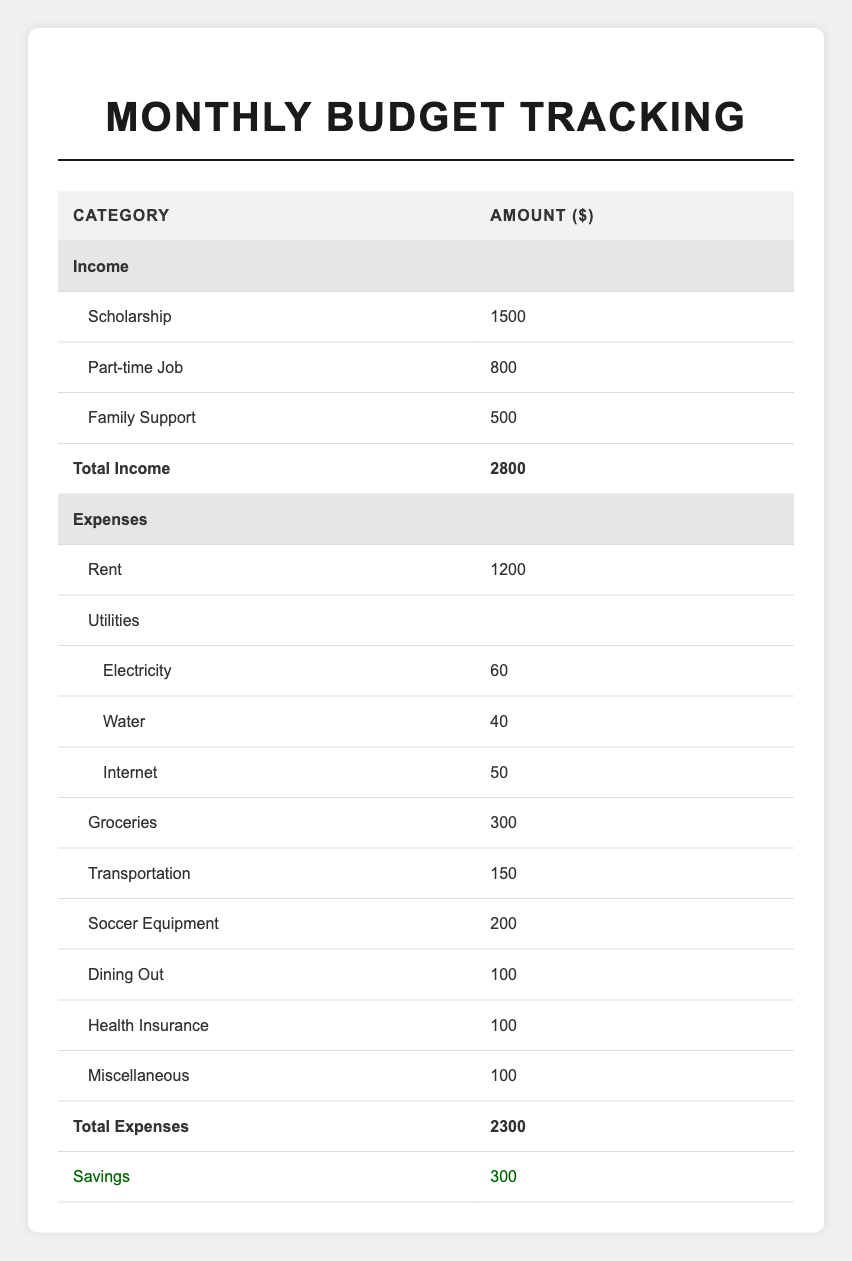What is the total income for the month? The table shows three sources of income: Scholarship (1500), Part-time Job (800), and Family Support (500). Adding these amounts together gives us 1500 + 800 + 500 = 2800.
Answer: 2800 What are the total expenses for the month? The table lists several expenses, with the total calculated as Rent (1200) + Utilities (60+40+50) + Groceries (300) + Transportation (150) + Soccer Equipment (200) + Dining Out (100) + Health Insurance (100) + Miscellaneous (100). Summing these values gives us 1200 + (60 + 40 + 50) + 300 + 150 + 200 + 100 + 100 + 100 = 2300.
Answer: 2300 What is the amount spent on utilities? The table provides the utility costs as Electricity (60), Water (40), and Internet (50). The total for utilities therefore is 60 + 40 + 50 = 150.
Answer: 150 Did the student save money this month? The table shows that the student has a savings amount of 300. Since savings are present, the answer is yes.
Answer: Yes How much more money does the student make than they spend? To determine this, we take the total income (2800) and subtract the total expenses (2300): 2800 - 2300 = 500.
Answer: 500 What percentage of their income did the student spend on rent? The rent expense is 1200 and total income is 2800. The calculation is (1200 / 2800) * 100, which equals approximately 42.86%.
Answer: 42.86% If the student wants to save an additional 200 next month, how much can they spend on expenses? The student currently saves 300. To save an additional 200, they would want to save a total of 500. To find the maximum spending limit, we subtract the desired savings from total income: 2800 - 500 = 2300. Thus, they can spend 2300 on expenses.
Answer: 2300 What categories have expenses less than 200 dollars? The table lists expenses for “Dining Out” (100), “Health Insurance” (100), and “Miscellaneous” (100) as categories with amounts below 200.
Answer: Dining Out, Health Insurance, Miscellaneous How much does the student spend on groceries compared to transportation? The student spends 300 on groceries and 150 on transportation. The difference is 300 - 150 = 150, meaning they spend 150 dollars more on groceries than on transportation.
Answer: 150 What is the average spending on each sub-category of utilities? The utility costs are Electricity (60), Water (40), and Internet (50). To find the average, we calculate (60 + 40 + 50) / 3 = 50.
Answer: 50 